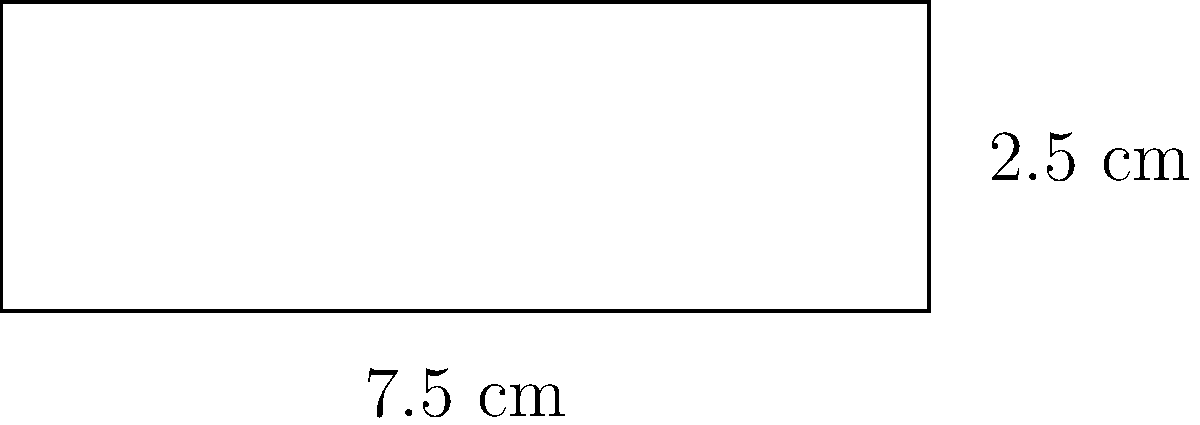As a parasitologist, you're preparing blood smear slides for malaria screening. The slide's dimensions are 7.5 cm in length and 2.5 cm in width. If you need to seal the edges of the slide with a special adhesive, what is the total length of adhesive needed to cover the entire perimeter of the slide? To find the perimeter of the blood smear slide, we need to calculate the sum of all its sides. The slide is rectangular, so we can use the formula for the perimeter of a rectangle:

$$P = 2l + 2w$$

Where:
$P$ = perimeter
$l$ = length
$w$ = width

Given:
Length ($l$) = 7.5 cm
Width ($w$) = 2.5 cm

Let's substitute these values into the formula:

$$P = 2(7.5 \text{ cm}) + 2(2.5 \text{ cm})$$
$$P = 15 \text{ cm} + 5 \text{ cm}$$
$$P = 20 \text{ cm}$$

Therefore, the total length of adhesive needed to cover the entire perimeter of the slide is 20 cm.
Answer: 20 cm 